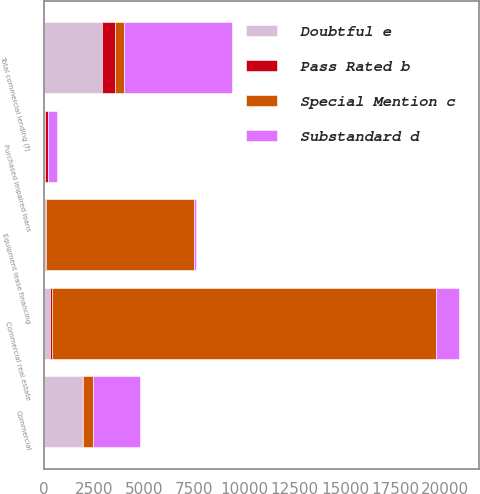<chart> <loc_0><loc_0><loc_500><loc_500><stacked_bar_chart><ecel><fcel>Commercial<fcel>Commercial real estate<fcel>Equipment lease financing<fcel>Purchased impaired loans<fcel>Total commercial lending (f)<nl><fcel>Special Mention c<fcel>469<fcel>19175<fcel>7403<fcel>10<fcel>469<nl><fcel>Doubtful e<fcel>1894<fcel>301<fcel>77<fcel>31<fcel>2871<nl><fcel>Substandard d<fcel>2352<fcel>1113<fcel>93<fcel>469<fcel>5366<nl><fcel>Pass Rated b<fcel>72<fcel>86<fcel>3<fcel>163<fcel>648<nl></chart> 